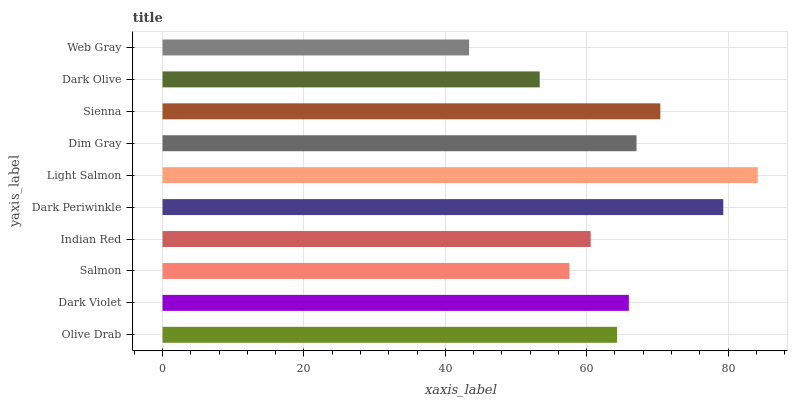Is Web Gray the minimum?
Answer yes or no. Yes. Is Light Salmon the maximum?
Answer yes or no. Yes. Is Dark Violet the minimum?
Answer yes or no. No. Is Dark Violet the maximum?
Answer yes or no. No. Is Dark Violet greater than Olive Drab?
Answer yes or no. Yes. Is Olive Drab less than Dark Violet?
Answer yes or no. Yes. Is Olive Drab greater than Dark Violet?
Answer yes or no. No. Is Dark Violet less than Olive Drab?
Answer yes or no. No. Is Dark Violet the high median?
Answer yes or no. Yes. Is Olive Drab the low median?
Answer yes or no. Yes. Is Web Gray the high median?
Answer yes or no. No. Is Dim Gray the low median?
Answer yes or no. No. 